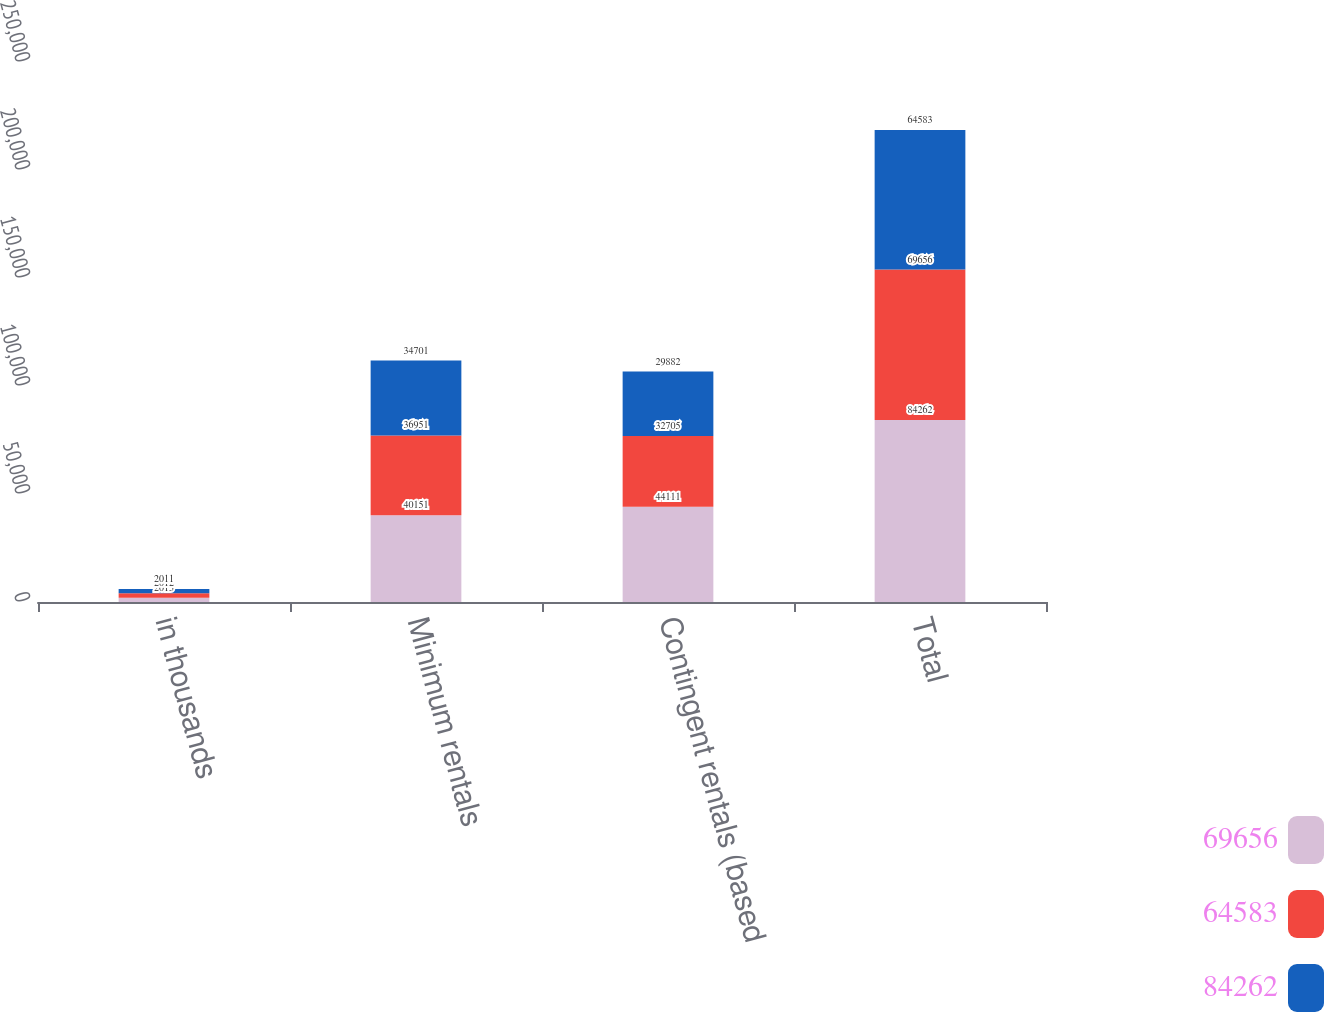Convert chart to OTSL. <chart><loc_0><loc_0><loc_500><loc_500><stacked_bar_chart><ecel><fcel>in thousands<fcel>Minimum rentals<fcel>Contingent rentals (based<fcel>Total<nl><fcel>69656<fcel>2013<fcel>40151<fcel>44111<fcel>84262<nl><fcel>64583<fcel>2012<fcel>36951<fcel>32705<fcel>69656<nl><fcel>84262<fcel>2011<fcel>34701<fcel>29882<fcel>64583<nl></chart> 